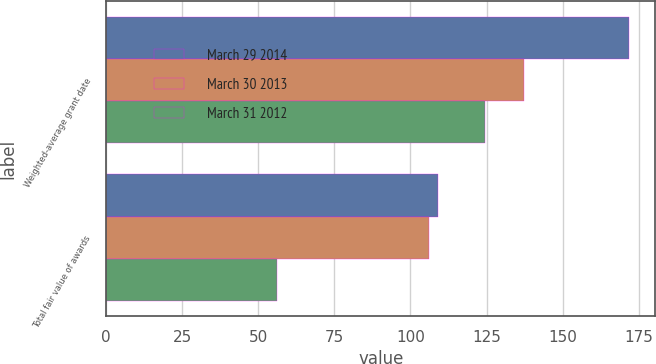Convert chart to OTSL. <chart><loc_0><loc_0><loc_500><loc_500><stacked_bar_chart><ecel><fcel>Weighted-average grant date<fcel>Total fair value of awards<nl><fcel>March 29 2014<fcel>171.93<fcel>109<nl><fcel>March 30 2013<fcel>137.45<fcel>106<nl><fcel>March 31 2012<fcel>124.43<fcel>56<nl></chart> 